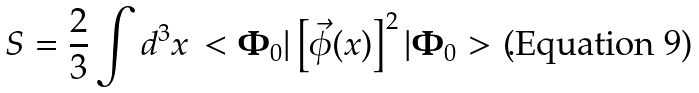<formula> <loc_0><loc_0><loc_500><loc_500>S = \frac { 2 } { 3 } \int d ^ { 3 } x \, < { \mathbf \Phi _ { 0 } } | \left [ \vec { \phi } ( x ) \right ] ^ { 2 } | { \mathbf \Phi _ { 0 } } > \, .</formula> 